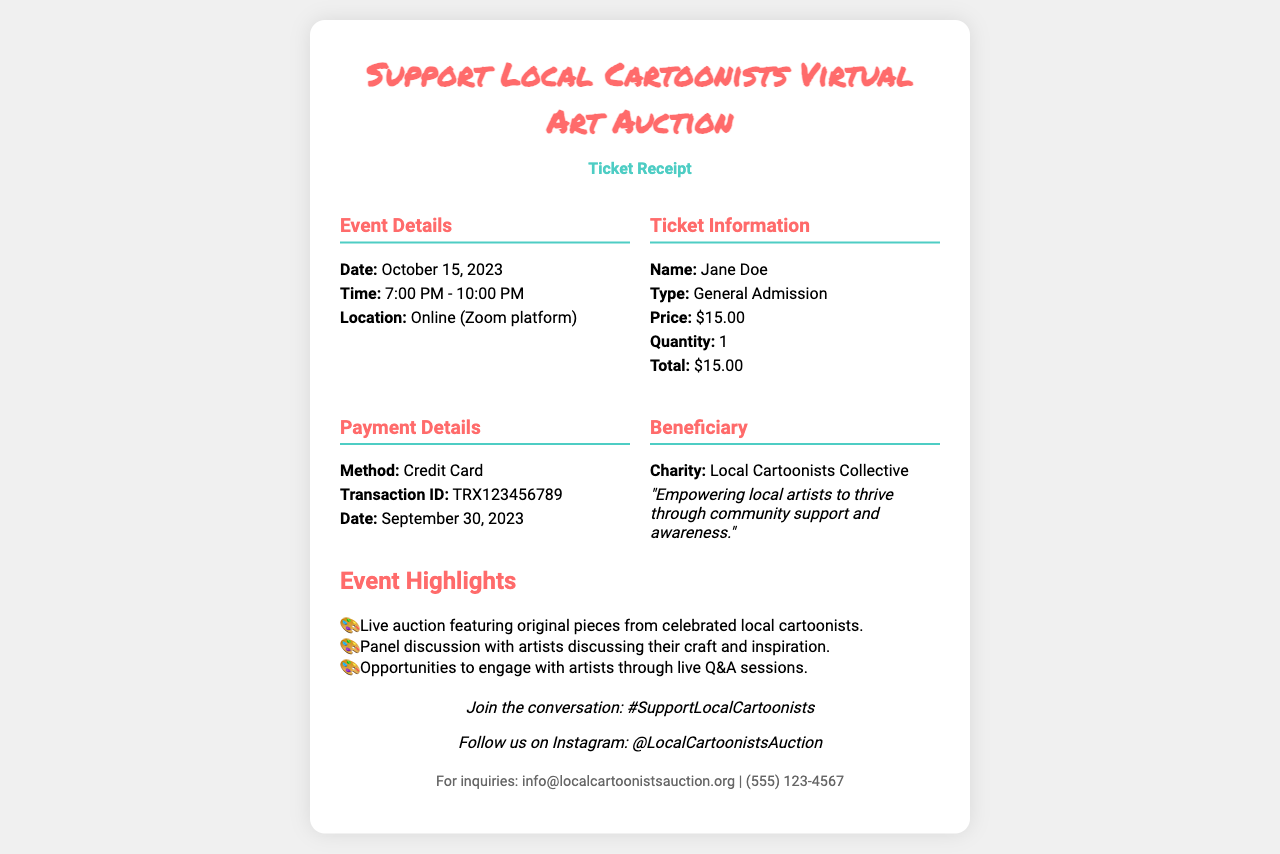What is the date of the event? The date of the event is specified in the details section, which reads October 15, 2023.
Answer: October 15, 2023 What time does the auction start? The receipt lists the start time of the event, which is 7:00 PM.
Answer: 7:00 PM Who is the ticket purchaser? The details section provides the name of the ticket purchaser as Jane Doe.
Answer: Jane Doe What is the total price of the ticket? The total price can be found in the ticket information section, which shows it as $15.00.
Answer: $15.00 What is the payment method used? The method of payment is indicated in the payment details section, which is Credit Card.
Answer: Credit Card How many tickets were purchased? The quantity of tickets is mentioned in the ticket information section, which states 1.
Answer: 1 What is the charity benefiting from the auction? The beneficiary section states that the charity is the Local Cartoonists Collective.
Answer: Local Cartoonists Collective What feature is highlighted in the event details? The highlights section mentions original pieces from celebrated local cartoonists as a feature of the auction.
Answer: Original pieces from celebrated local cartoonists What is the fundraising goal of this event? The goal can be inferred from the beneficiary's statement about empowering local artists, suggesting community support as a primary aim.
Answer: Community support 